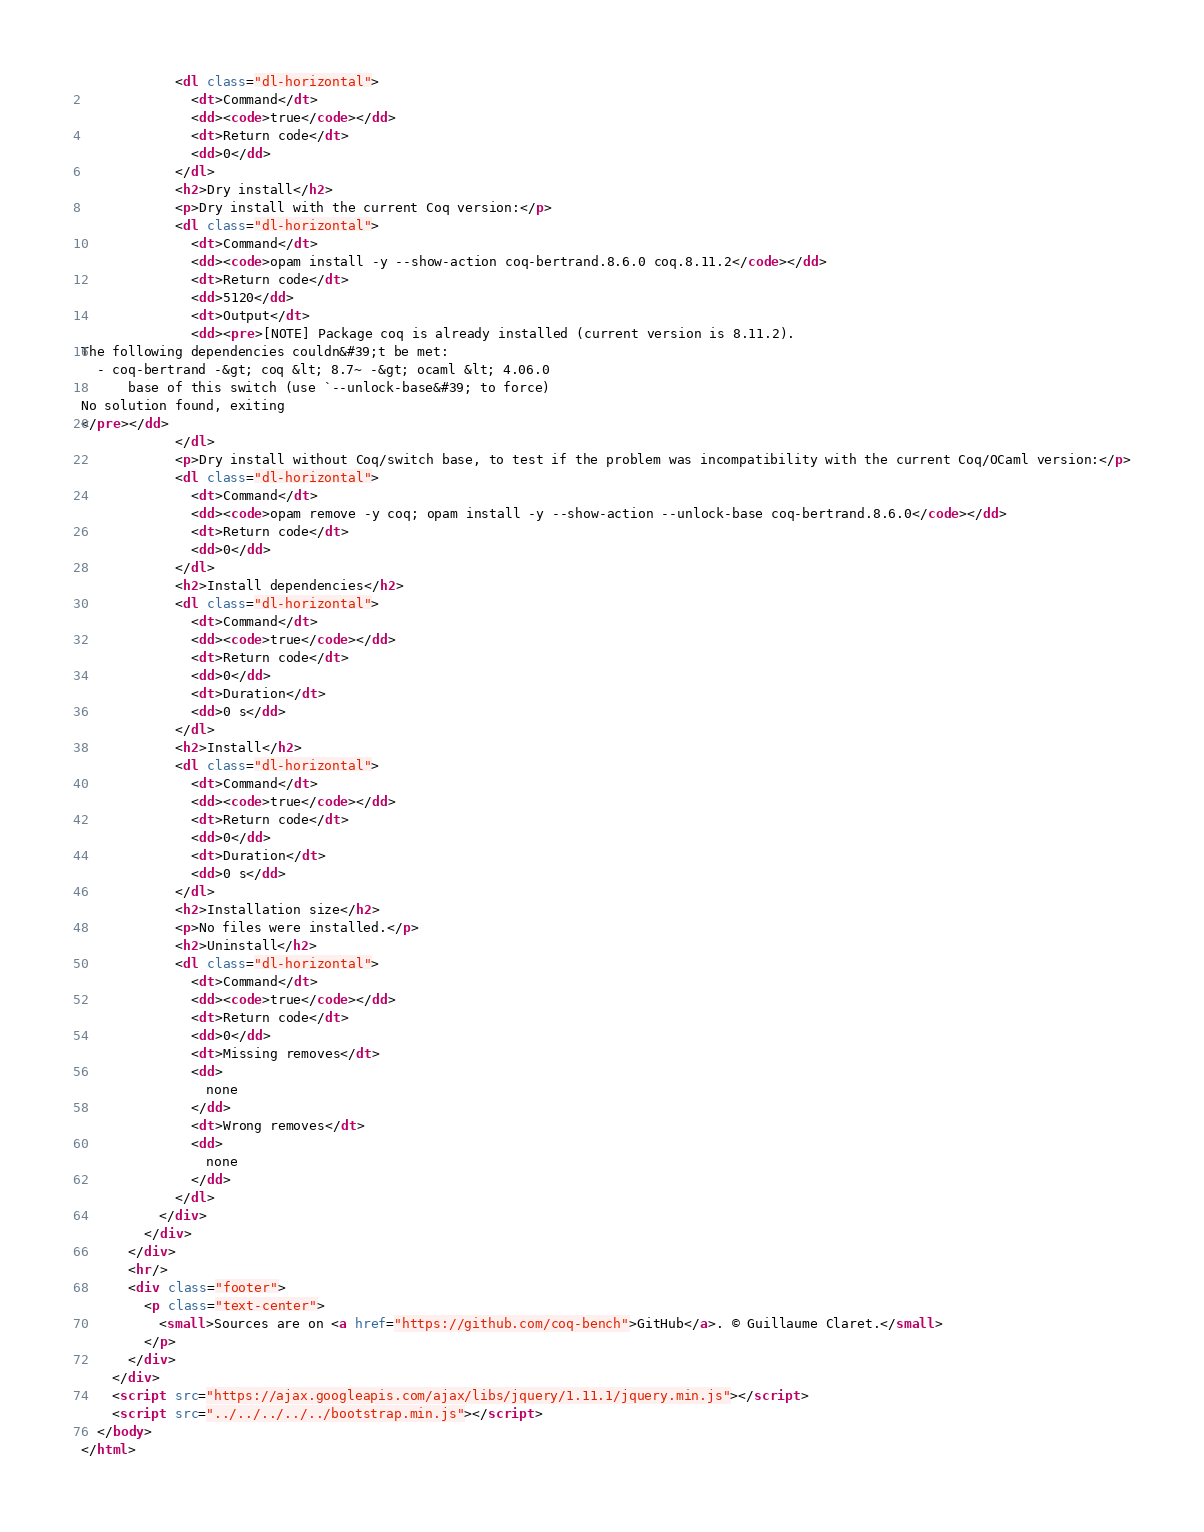<code> <loc_0><loc_0><loc_500><loc_500><_HTML_>            <dl class="dl-horizontal">
              <dt>Command</dt>
              <dd><code>true</code></dd>
              <dt>Return code</dt>
              <dd>0</dd>
            </dl>
            <h2>Dry install</h2>
            <p>Dry install with the current Coq version:</p>
            <dl class="dl-horizontal">
              <dt>Command</dt>
              <dd><code>opam install -y --show-action coq-bertrand.8.6.0 coq.8.11.2</code></dd>
              <dt>Return code</dt>
              <dd>5120</dd>
              <dt>Output</dt>
              <dd><pre>[NOTE] Package coq is already installed (current version is 8.11.2).
The following dependencies couldn&#39;t be met:
  - coq-bertrand -&gt; coq &lt; 8.7~ -&gt; ocaml &lt; 4.06.0
      base of this switch (use `--unlock-base&#39; to force)
No solution found, exiting
</pre></dd>
            </dl>
            <p>Dry install without Coq/switch base, to test if the problem was incompatibility with the current Coq/OCaml version:</p>
            <dl class="dl-horizontal">
              <dt>Command</dt>
              <dd><code>opam remove -y coq; opam install -y --show-action --unlock-base coq-bertrand.8.6.0</code></dd>
              <dt>Return code</dt>
              <dd>0</dd>
            </dl>
            <h2>Install dependencies</h2>
            <dl class="dl-horizontal">
              <dt>Command</dt>
              <dd><code>true</code></dd>
              <dt>Return code</dt>
              <dd>0</dd>
              <dt>Duration</dt>
              <dd>0 s</dd>
            </dl>
            <h2>Install</h2>
            <dl class="dl-horizontal">
              <dt>Command</dt>
              <dd><code>true</code></dd>
              <dt>Return code</dt>
              <dd>0</dd>
              <dt>Duration</dt>
              <dd>0 s</dd>
            </dl>
            <h2>Installation size</h2>
            <p>No files were installed.</p>
            <h2>Uninstall</h2>
            <dl class="dl-horizontal">
              <dt>Command</dt>
              <dd><code>true</code></dd>
              <dt>Return code</dt>
              <dd>0</dd>
              <dt>Missing removes</dt>
              <dd>
                none
              </dd>
              <dt>Wrong removes</dt>
              <dd>
                none
              </dd>
            </dl>
          </div>
        </div>
      </div>
      <hr/>
      <div class="footer">
        <p class="text-center">
          <small>Sources are on <a href="https://github.com/coq-bench">GitHub</a>. © Guillaume Claret.</small>
        </p>
      </div>
    </div>
    <script src="https://ajax.googleapis.com/ajax/libs/jquery/1.11.1/jquery.min.js"></script>
    <script src="../../../../../bootstrap.min.js"></script>
  </body>
</html>
</code> 